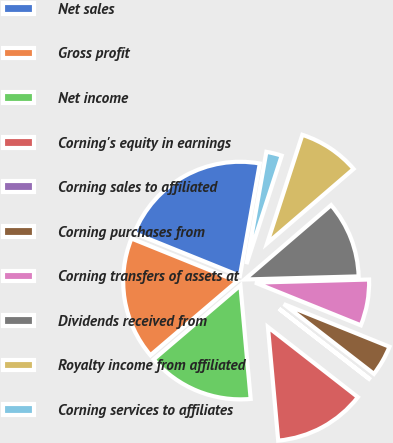Convert chart. <chart><loc_0><loc_0><loc_500><loc_500><pie_chart><fcel>Net sales<fcel>Gross profit<fcel>Net income<fcel>Corning's equity in earnings<fcel>Corning sales to affiliated<fcel>Corning purchases from<fcel>Corning transfers of assets at<fcel>Dividends received from<fcel>Royalty income from affiliated<fcel>Corning services to affiliates<nl><fcel>21.68%<fcel>17.35%<fcel>15.19%<fcel>13.03%<fcel>0.05%<fcel>4.38%<fcel>6.54%<fcel>10.87%<fcel>8.7%<fcel>2.21%<nl></chart> 